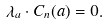<formula> <loc_0><loc_0><loc_500><loc_500>\lambda _ { a } \cdot C _ { n } ( a ) = 0 .</formula> 